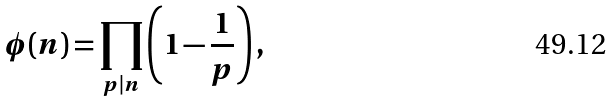<formula> <loc_0><loc_0><loc_500><loc_500>\phi ( n ) = \prod _ { p | n } \left ( 1 - \frac { 1 } { p } \right ) ,</formula> 